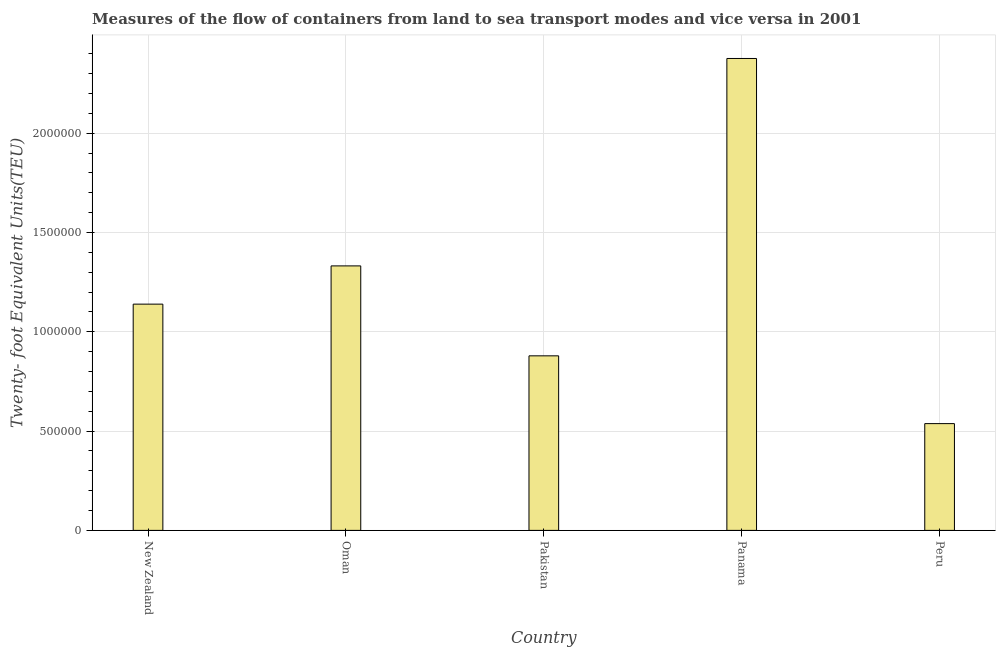Does the graph contain any zero values?
Provide a succinct answer. No. Does the graph contain grids?
Your answer should be very brief. Yes. What is the title of the graph?
Offer a very short reply. Measures of the flow of containers from land to sea transport modes and vice versa in 2001. What is the label or title of the Y-axis?
Give a very brief answer. Twenty- foot Equivalent Units(TEU). What is the container port traffic in Peru?
Offer a very short reply. 5.38e+05. Across all countries, what is the maximum container port traffic?
Ensure brevity in your answer.  2.38e+06. Across all countries, what is the minimum container port traffic?
Your answer should be very brief. 5.38e+05. In which country was the container port traffic maximum?
Ensure brevity in your answer.  Panama. What is the sum of the container port traffic?
Offer a very short reply. 6.26e+06. What is the difference between the container port traffic in Oman and Panama?
Keep it short and to the point. -1.04e+06. What is the average container port traffic per country?
Offer a terse response. 1.25e+06. What is the median container port traffic?
Provide a short and direct response. 1.14e+06. In how many countries, is the container port traffic greater than 2100000 TEU?
Provide a succinct answer. 1. What is the ratio of the container port traffic in New Zealand to that in Panama?
Your response must be concise. 0.48. What is the difference between the highest and the second highest container port traffic?
Offer a very short reply. 1.04e+06. Is the sum of the container port traffic in Oman and Panama greater than the maximum container port traffic across all countries?
Provide a short and direct response. Yes. What is the difference between the highest and the lowest container port traffic?
Ensure brevity in your answer.  1.84e+06. In how many countries, is the container port traffic greater than the average container port traffic taken over all countries?
Offer a terse response. 2. How many countries are there in the graph?
Provide a short and direct response. 5. What is the difference between two consecutive major ticks on the Y-axis?
Your answer should be very brief. 5.00e+05. What is the Twenty- foot Equivalent Units(TEU) of New Zealand?
Keep it short and to the point. 1.14e+06. What is the Twenty- foot Equivalent Units(TEU) in Oman?
Your answer should be very brief. 1.33e+06. What is the Twenty- foot Equivalent Units(TEU) in Pakistan?
Your answer should be very brief. 8.79e+05. What is the Twenty- foot Equivalent Units(TEU) of Panama?
Provide a short and direct response. 2.38e+06. What is the Twenty- foot Equivalent Units(TEU) of Peru?
Ensure brevity in your answer.  5.38e+05. What is the difference between the Twenty- foot Equivalent Units(TEU) in New Zealand and Oman?
Your answer should be very brief. -1.93e+05. What is the difference between the Twenty- foot Equivalent Units(TEU) in New Zealand and Pakistan?
Provide a succinct answer. 2.60e+05. What is the difference between the Twenty- foot Equivalent Units(TEU) in New Zealand and Panama?
Your answer should be very brief. -1.24e+06. What is the difference between the Twenty- foot Equivalent Units(TEU) in New Zealand and Peru?
Provide a succinct answer. 6.02e+05. What is the difference between the Twenty- foot Equivalent Units(TEU) in Oman and Pakistan?
Give a very brief answer. 4.53e+05. What is the difference between the Twenty- foot Equivalent Units(TEU) in Oman and Panama?
Give a very brief answer. -1.04e+06. What is the difference between the Twenty- foot Equivalent Units(TEU) in Oman and Peru?
Your answer should be compact. 7.94e+05. What is the difference between the Twenty- foot Equivalent Units(TEU) in Pakistan and Panama?
Offer a terse response. -1.50e+06. What is the difference between the Twenty- foot Equivalent Units(TEU) in Pakistan and Peru?
Ensure brevity in your answer.  3.41e+05. What is the difference between the Twenty- foot Equivalent Units(TEU) in Panama and Peru?
Your response must be concise. 1.84e+06. What is the ratio of the Twenty- foot Equivalent Units(TEU) in New Zealand to that in Oman?
Provide a succinct answer. 0.85. What is the ratio of the Twenty- foot Equivalent Units(TEU) in New Zealand to that in Pakistan?
Your answer should be very brief. 1.3. What is the ratio of the Twenty- foot Equivalent Units(TEU) in New Zealand to that in Panama?
Your response must be concise. 0.48. What is the ratio of the Twenty- foot Equivalent Units(TEU) in New Zealand to that in Peru?
Provide a short and direct response. 2.12. What is the ratio of the Twenty- foot Equivalent Units(TEU) in Oman to that in Pakistan?
Your response must be concise. 1.51. What is the ratio of the Twenty- foot Equivalent Units(TEU) in Oman to that in Panama?
Provide a succinct answer. 0.56. What is the ratio of the Twenty- foot Equivalent Units(TEU) in Oman to that in Peru?
Keep it short and to the point. 2.48. What is the ratio of the Twenty- foot Equivalent Units(TEU) in Pakistan to that in Panama?
Your response must be concise. 0.37. What is the ratio of the Twenty- foot Equivalent Units(TEU) in Pakistan to that in Peru?
Keep it short and to the point. 1.64. What is the ratio of the Twenty- foot Equivalent Units(TEU) in Panama to that in Peru?
Your answer should be very brief. 4.42. 